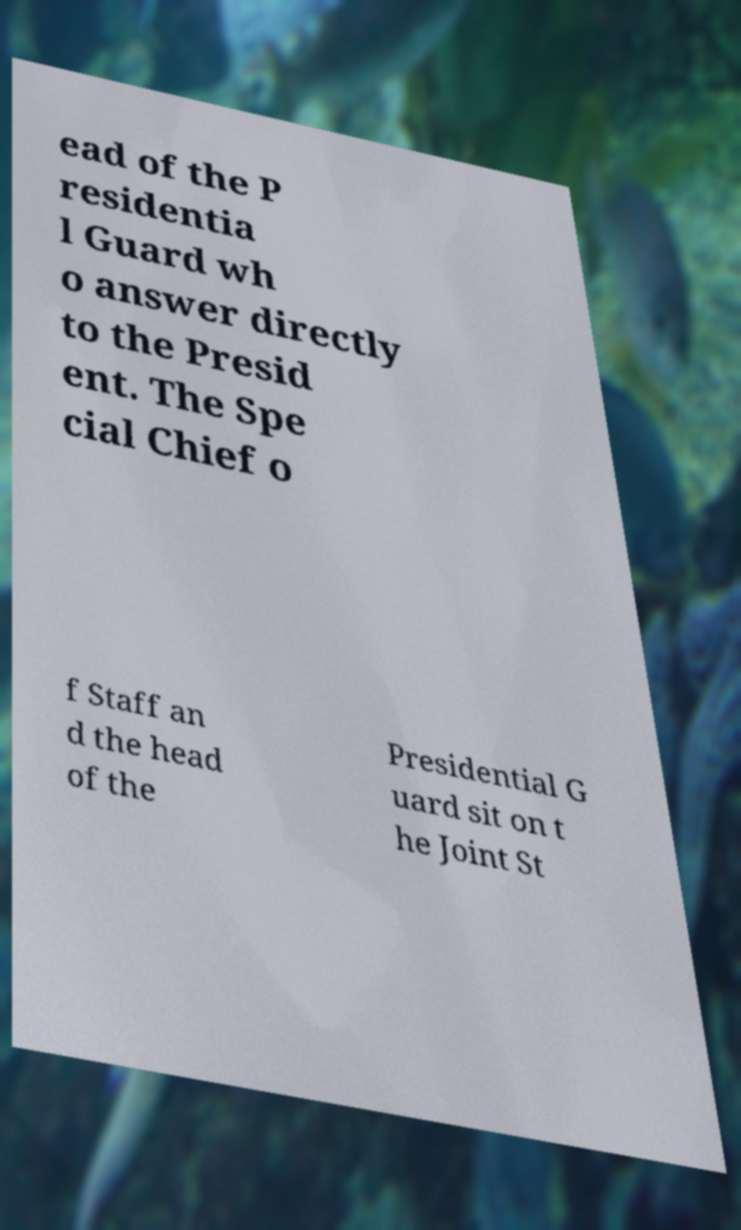I need the written content from this picture converted into text. Can you do that? ead of the P residentia l Guard wh o answer directly to the Presid ent. The Spe cial Chief o f Staff an d the head of the Presidential G uard sit on t he Joint St 